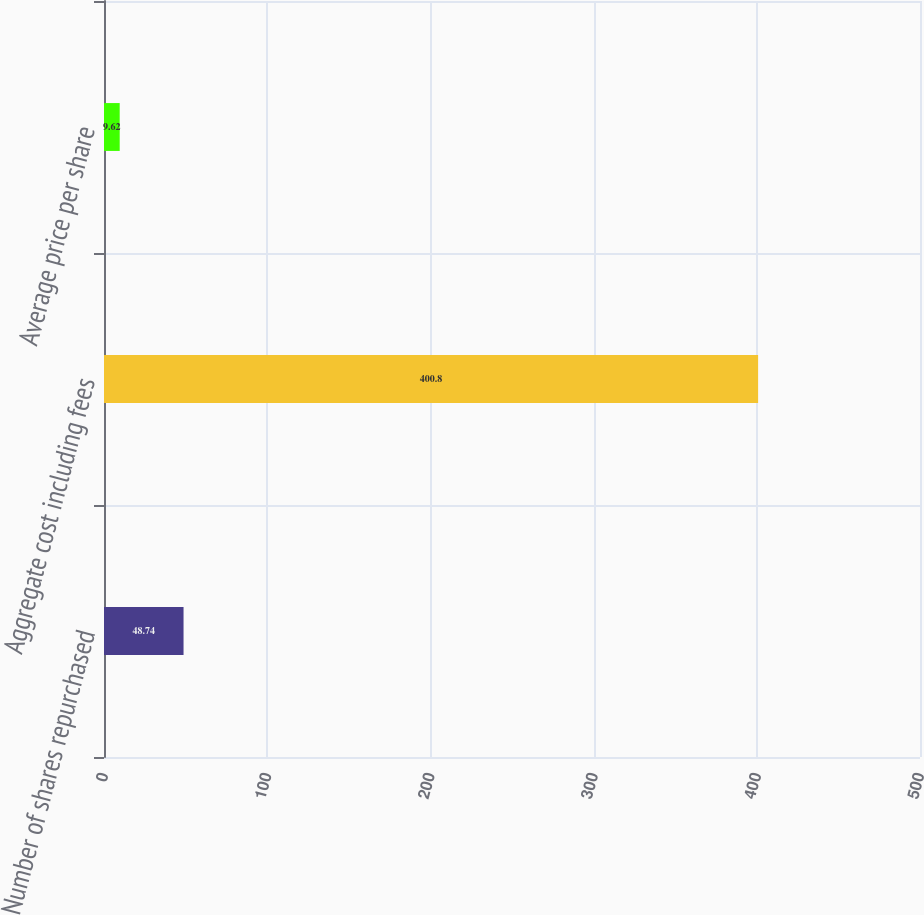Convert chart to OTSL. <chart><loc_0><loc_0><loc_500><loc_500><bar_chart><fcel>Number of shares repurchased<fcel>Aggregate cost including fees<fcel>Average price per share<nl><fcel>48.74<fcel>400.8<fcel>9.62<nl></chart> 